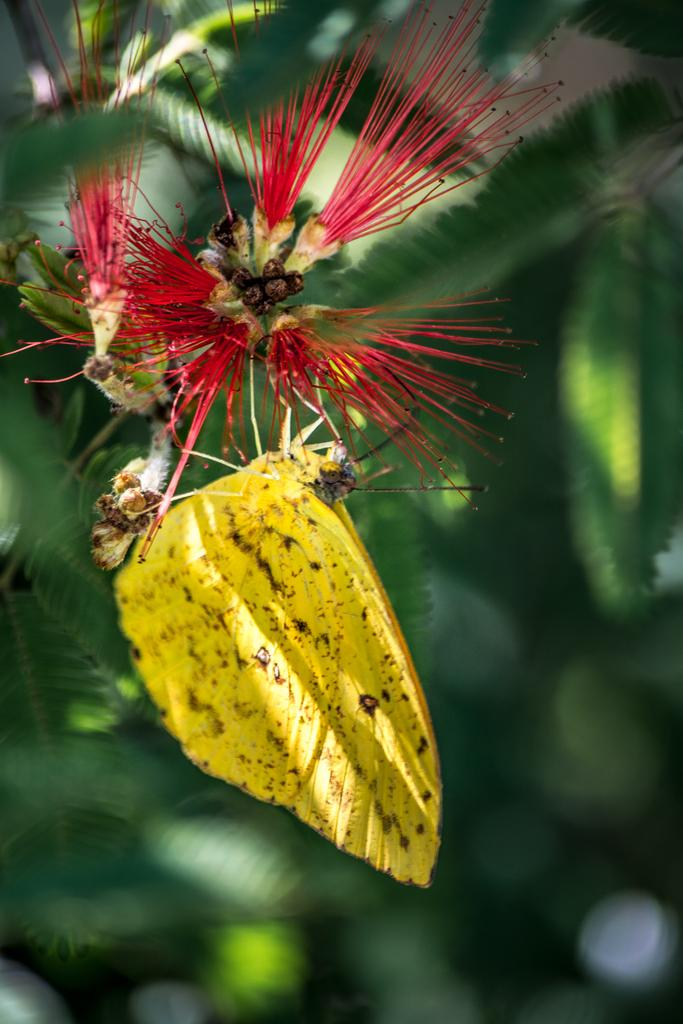What is the main subject of the image? There is a butterfly in the image. Where is the butterfly located? The butterfly is on a flower. Can you describe the background of the image? The background of the image is blurry. How many babies are present on the hill in the image? There are no babies or hills present in the image; it features a butterfly on a flower with a blurry background. 